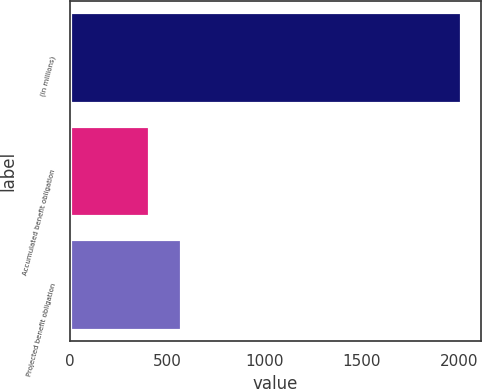Convert chart. <chart><loc_0><loc_0><loc_500><loc_500><bar_chart><fcel>(in millions)<fcel>Accumulated benefit obligation<fcel>Projected benefit obligation<nl><fcel>2013<fcel>408<fcel>568.5<nl></chart> 